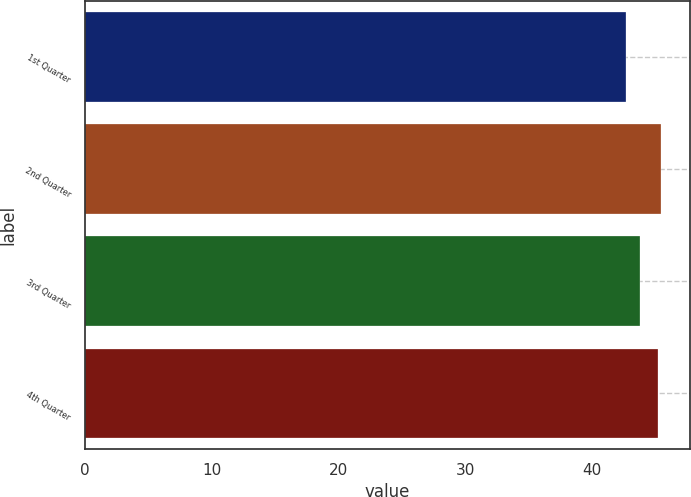Convert chart. <chart><loc_0><loc_0><loc_500><loc_500><bar_chart><fcel>1st Quarter<fcel>2nd Quarter<fcel>3rd Quarter<fcel>4th Quarter<nl><fcel>42.66<fcel>45.43<fcel>43.8<fcel>45.16<nl></chart> 